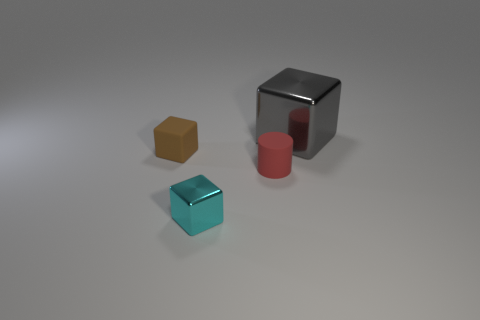Does the small object to the left of the small cyan shiny thing have the same shape as the big thing behind the rubber cylinder?
Make the answer very short. Yes. There is a shiny block that is behind the matte thing left of the cyan object; what number of red matte things are left of it?
Offer a terse response. 1. What color is the matte block?
Offer a very short reply. Brown. How many other objects are the same size as the cyan metal object?
Provide a short and direct response. 2. What is the material of the other brown thing that is the same shape as the large shiny thing?
Provide a short and direct response. Rubber. There is a tiny red cylinder that is in front of the thing that is left of the shiny object in front of the big gray cube; what is its material?
Keep it short and to the point. Rubber. What is the size of the other thing that is the same material as the tiny cyan thing?
Your answer should be very brief. Large. Is there any other thing that is the same color as the small cylinder?
Your response must be concise. No. Do the shiny thing that is on the left side of the big metal block and the metal object that is behind the tiny brown cube have the same color?
Provide a short and direct response. No. What is the color of the block that is behind the brown thing?
Your response must be concise. Gray. 